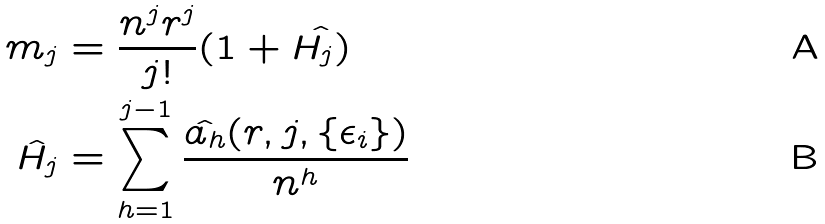Convert formula to latex. <formula><loc_0><loc_0><loc_500><loc_500>m _ { j } & = \frac { n ^ { j } r ^ { j } } { j ! } ( 1 + \hat { H _ { j } ) } \\ \hat { H _ { j } } & = \sum _ { h = 1 } ^ { j - 1 } \frac { \hat { a _ { h } } ( r , j , \{ \epsilon _ { i } \} ) } { n ^ { h } }</formula> 